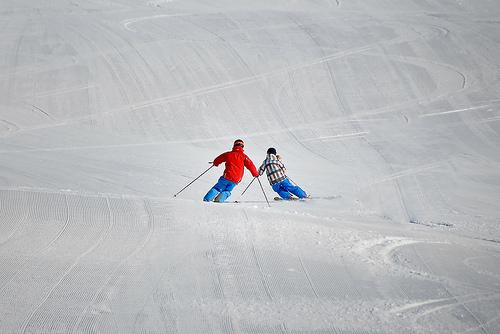Give a brief account of the main objects and activities portrayed in the picture. Two snow skiers wearing red jackets and blue pants are skiing while gripping ski poles. Provide a succinct description of the main objects and events in the image. Two individuals skiing in snow, clad in red jackets and blue pants, holding ski poles. What is happening in the image? Please describe it in a short sentence. Two people dressed in red jackets and blue pants are skiing together with ski poles in hand. Provide a simple description of the main subjects and their actions in the photo. Two skiers wearing red coats and blue pants skillfully ski together with ski poles. Briefly state the main action and subjects shown in the picture. Two skiers wearing a red coat and blue pants are skiing together, gripping ski poles. Mention the main elements and actions in the picture using short phrases. Skiers, red jackets, blue pants, ski poles, skiing on snow. In a brief sentence, describe the focal point of the image. Two skiers in red jackets and blue pants enjoy skiing while holding ski poles. What is the primary focus of the scene captured in the image? A pair of skiers wearing red jackets and blue pants, holding ski poles and skiing on snow. Describe the key elements and activities in the image with a concise sentence. Two skiers in red jackets and blue pants hold ski poles as they ski on snow. Identify the primary activity taking place in the image. Two people skiing in the snow while holding ski poles, wearing blue pants and red jackets. 